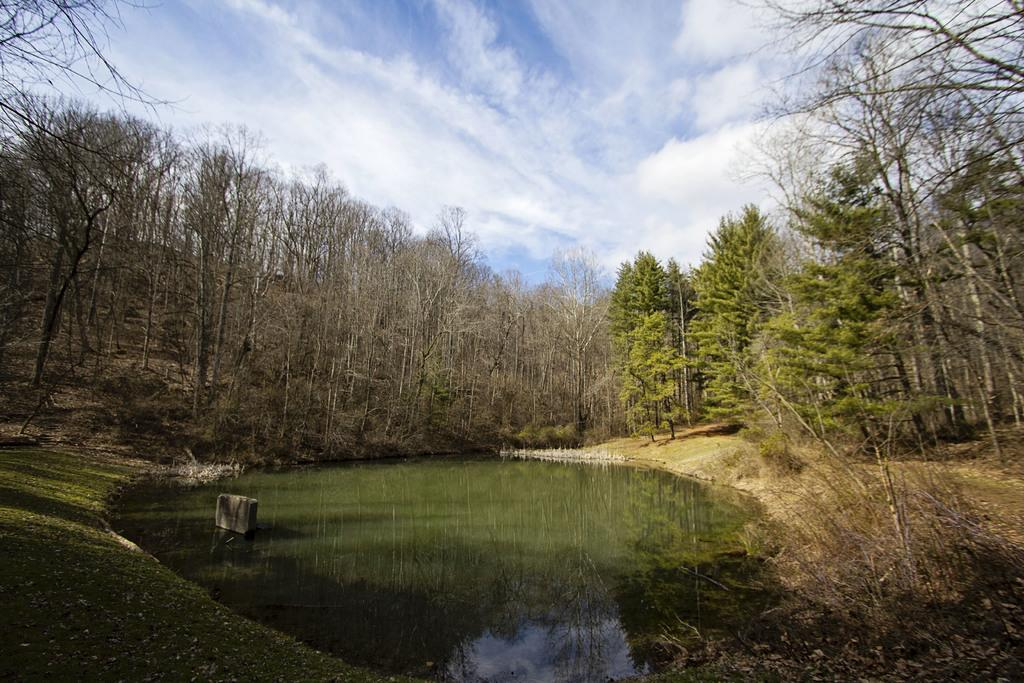What is the main subject in the center of the image? There is water in the center of the image. What type of vegetation can be seen in the image? There are trees visible in the image. What can be seen in the background of the image? The sky is visible in the background of the image. What type of texture does the potato have in the image? There is no potato present in the image, so it is not possible to determine its texture. 